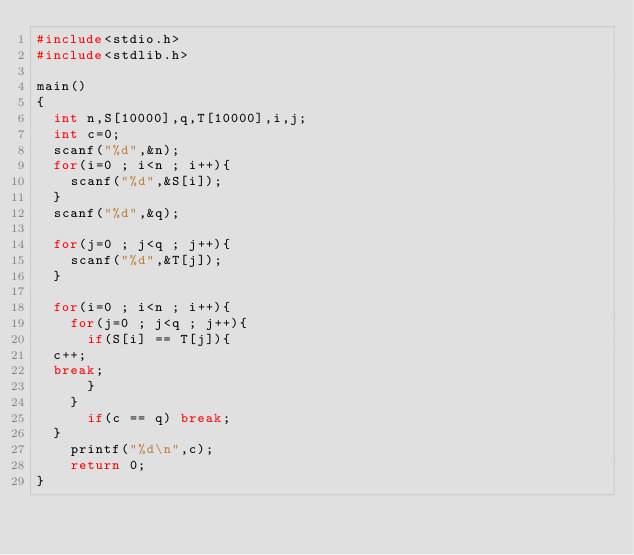<code> <loc_0><loc_0><loc_500><loc_500><_C_>#include<stdio.h>
#include<stdlib.h>

main()
{
  int n,S[10000],q,T[10000],i,j;
  int c=0;
  scanf("%d",&n);
  for(i=0 ; i<n ; i++){
    scanf("%d",&S[i]);
  }
  scanf("%d",&q);

  for(j=0 ; j<q ; j++){
    scanf("%d",&T[j]);
  }

  for(i=0 ; i<n ; i++){
    for(j=0 ; j<q ; j++){
      if(S[i] == T[j]){
	c++;
	break;
      }
    }
      if(c == q) break;
  }
    printf("%d\n",c);
    return 0;
}</code> 